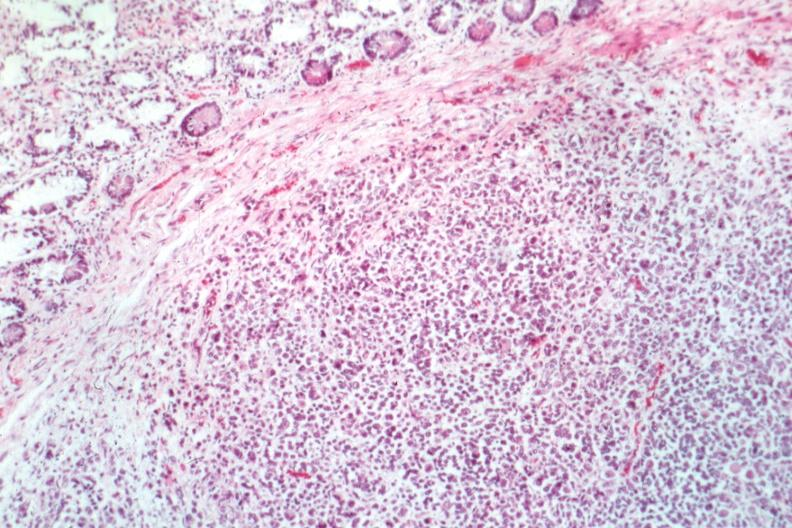what is?
Answer the question using a single word or phrase. The tumor 